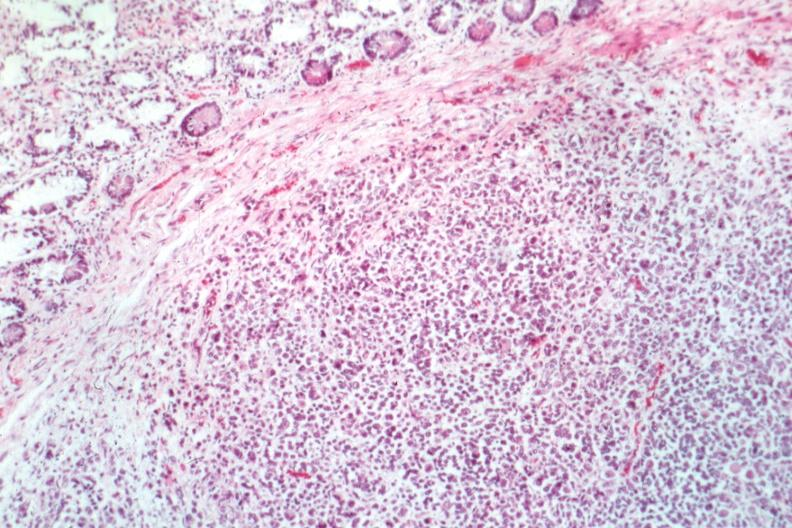what is?
Answer the question using a single word or phrase. The tumor 